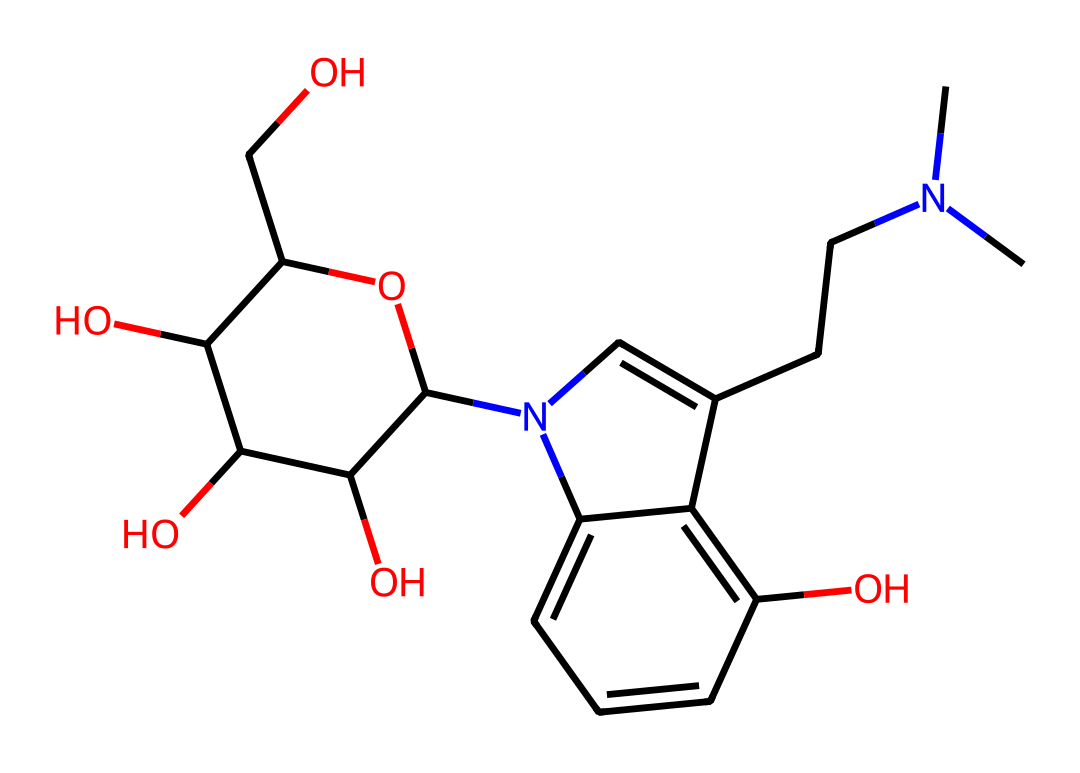What is the molecular formula of psilocybin? By analyzing the structure represented in the SMILES notation, we can break down the components. Counting the carbon (C), hydrogen (H), nitrogen (N), and oxygen (O) atoms, we find it consists of 12 carbon atoms, 17 hydrogen atoms, 2 nitrogen atoms, and 4 oxygen atoms. Therefore, the molecular formula is C12H17N2O4P.
Answer: C12H17N2O4P How many nitrogen atoms are present in psilocybin? In the provided SMILES, we can identify the nitrogen atoms by locating the N symbols. By counting, we find there are two nitrogen atoms present in the structure.
Answer: 2 Which functional group is characteristic of psilocybin? Psilocybin contains a phosphoryloxy group (-OPO(OH)2) as indicated by the presence of the phosphorus atom and multiple oxygens connected to it in the structure. This functional group is typical of phosphoric acid derivatives.
Answer: phosphoryloxy group What is the classification of psilocybin based on its psychoactive properties? Psilocybin is classified as a psychedelic compound due to its ability to alter perception and mood, which is consistent with the characteristics of many alkaloids that interact with neurotransmitter systems in the brain.
Answer: psychedelic Which part of the psilocybin structure contributes to its activity in the brain? The indole ring structure, characterized by the fused benzene and pyrrole rings, is critical for psilocybin's psychoactive effects as it closely resembles the structure of serotonin, a key neurotransmitter in the brain. Thus, the indole ring plays a significant role in the interaction with serotonin receptors.
Answer: indole ring What type of reaction typically modifies compounds like psilocybin in the body? Psilocybin undergoes dephosphorylation in the body, which is a common reaction in drug metabolism where a phosphate group is removed, converting it into psilocin, the active form that produces psychoactive effects.
Answer: dephosphorylation 